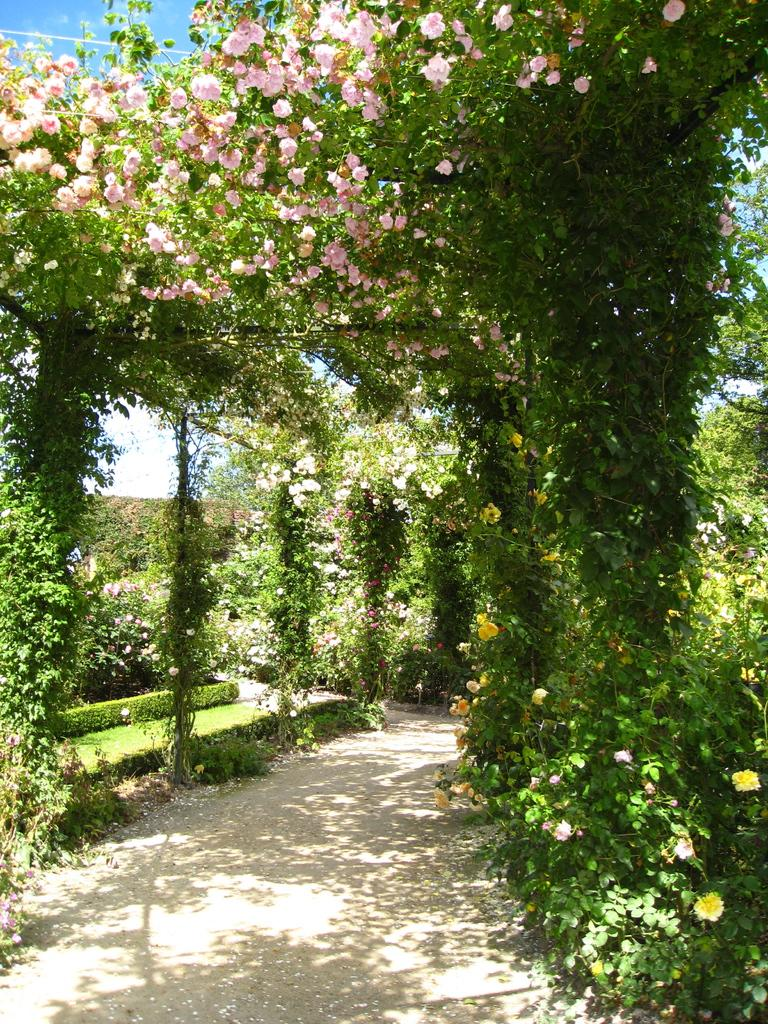What type of plants are visible in the image? There are flowers on the vine plants in the image. What can be seen in the background of the image? There are trees, plants, and grass in the background of the image. What part of the natural environment is visible in the image? The sky is visible in the top left corner of the image. What type of brass instrument is being played in the image? There is no brass instrument or any musical instrument present in the image. 